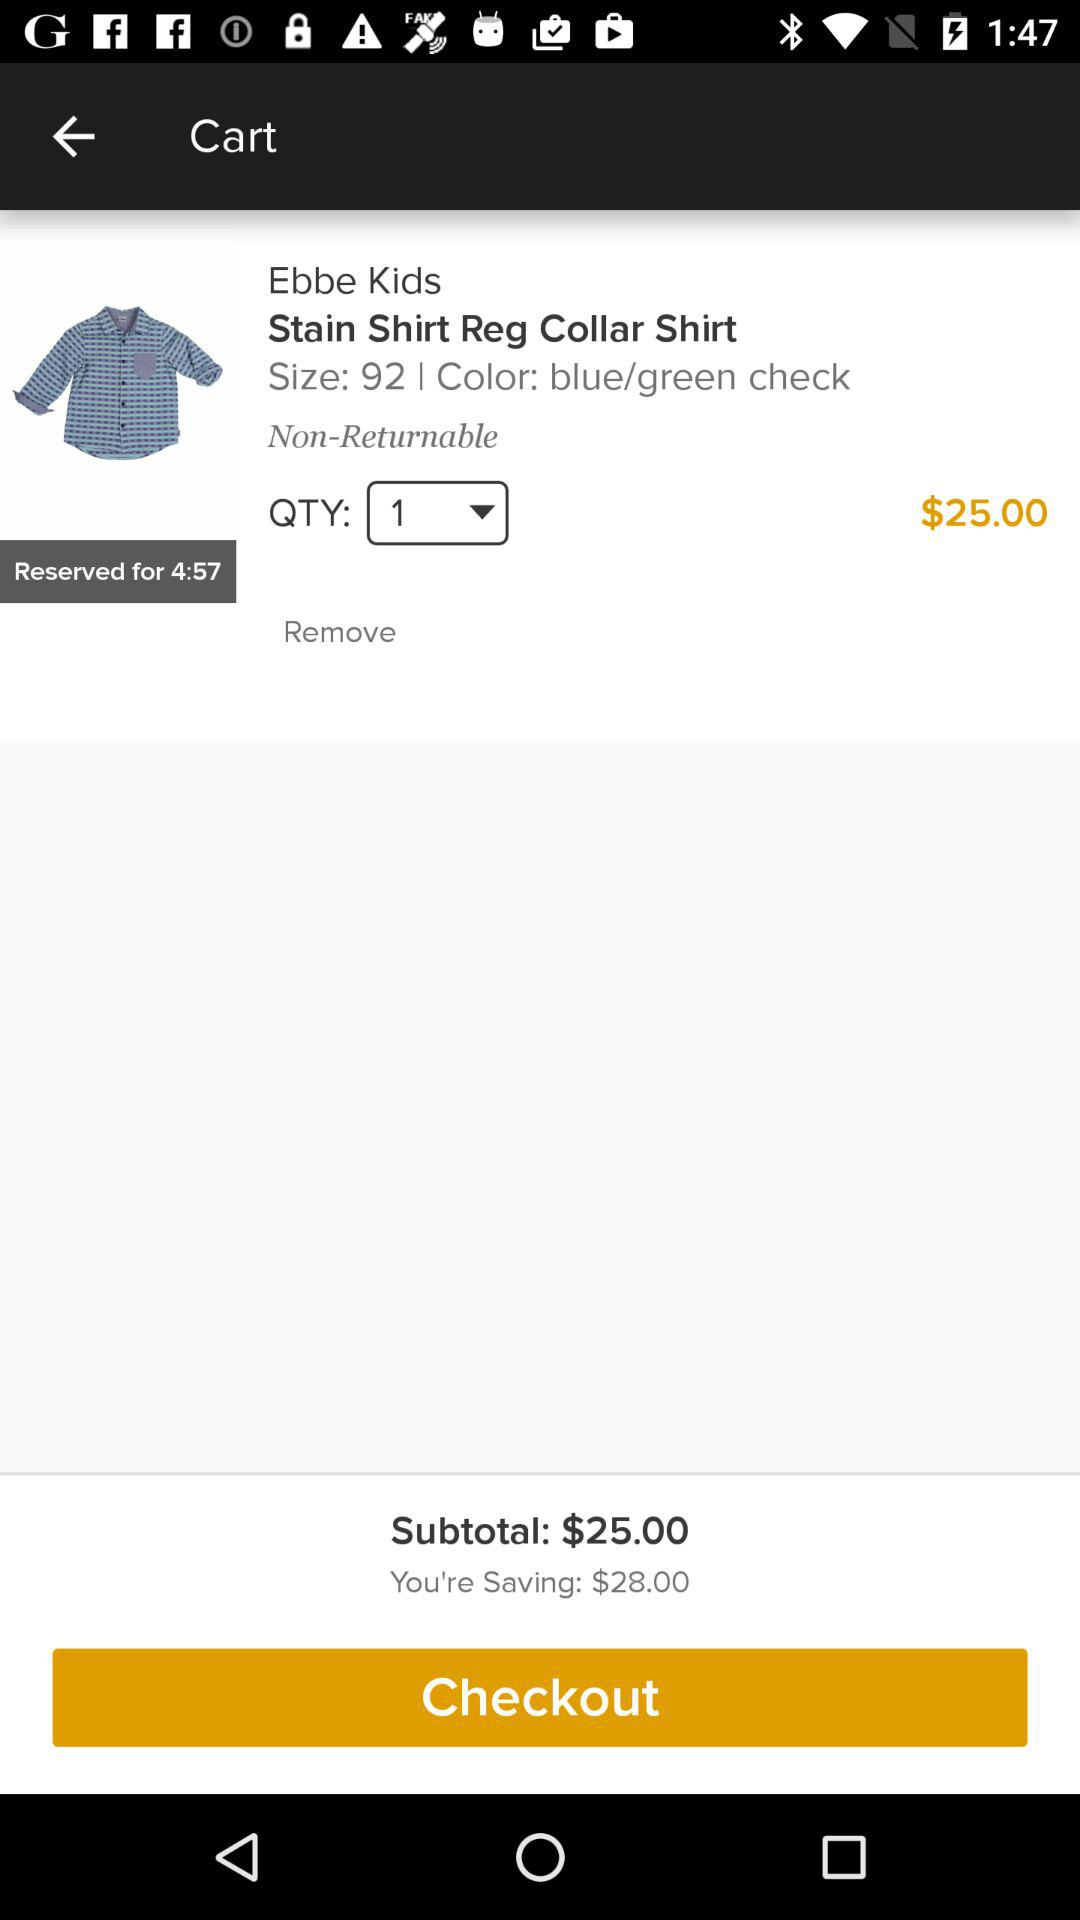What's the quantity? The quantity is 1. 